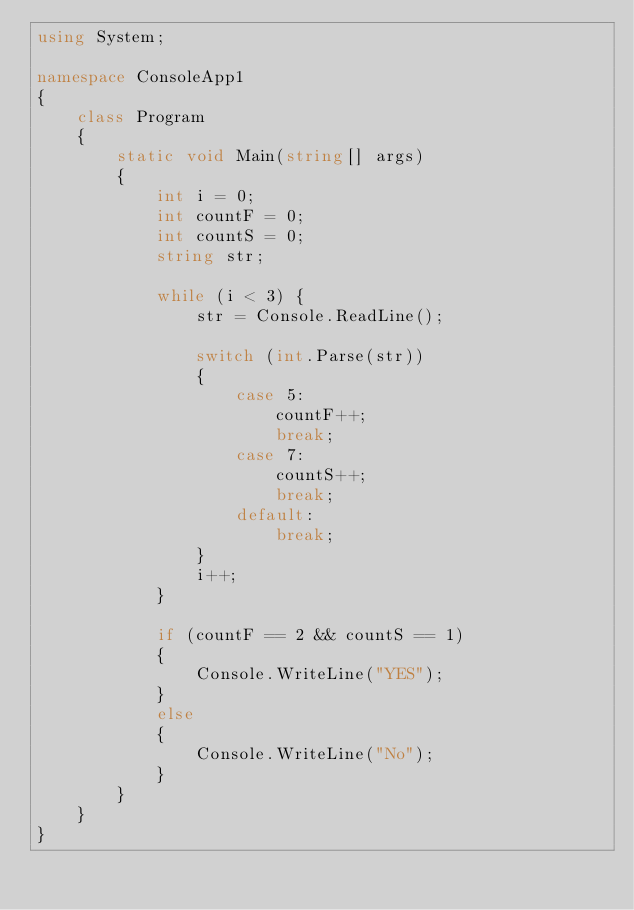<code> <loc_0><loc_0><loc_500><loc_500><_C#_>using System;

namespace ConsoleApp1
{
    class Program
    {
        static void Main(string[] args)
        {
            int i = 0;
            int countF = 0;
            int countS = 0;
            string str;

            while (i < 3) {
                str = Console.ReadLine();

                switch (int.Parse(str)) 
                {
                    case 5:
                        countF++;
                        break;
                    case 7:
                        countS++;
                        break;
                    default:
                        break;
                }
                i++;
            }

            if (countF == 2 && countS == 1)
            {
                Console.WriteLine("YES");
            }
            else 
            {
                Console.WriteLine("No");
            }
        }
    }
}</code> 